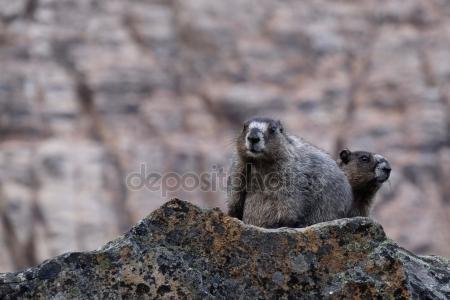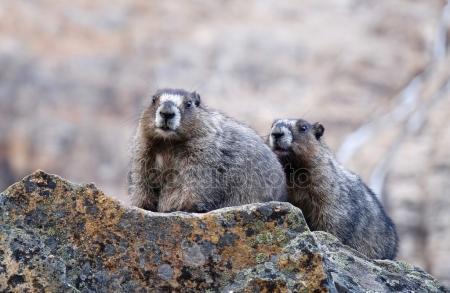The first image is the image on the left, the second image is the image on the right. For the images displayed, is the sentence "Each image contains one pair of marmots posed close together on a rock, and no marmots have their backs to the camera." factually correct? Answer yes or no. Yes. The first image is the image on the left, the second image is the image on the right. Given the left and right images, does the statement "On the right image, the two animals are facing the same direction." hold true? Answer yes or no. Yes. 